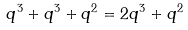Convert formula to latex. <formula><loc_0><loc_0><loc_500><loc_500>q ^ { 3 } + q ^ { 3 } + q ^ { 2 } = 2 q ^ { 3 } + q ^ { 2 }</formula> 